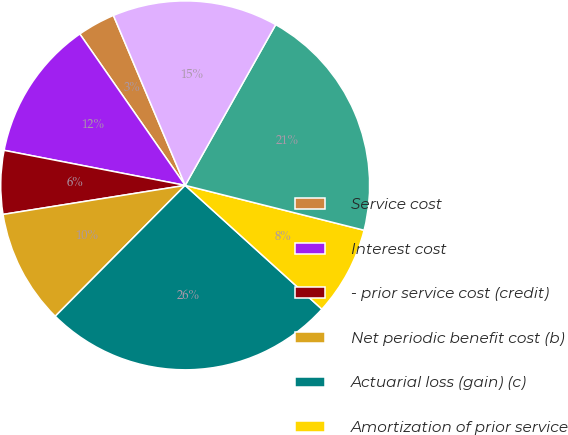<chart> <loc_0><loc_0><loc_500><loc_500><pie_chart><fcel>Service cost<fcel>Interest cost<fcel>- prior service cost (credit)<fcel>Net periodic benefit cost (b)<fcel>Actuarial loss (gain) (c)<fcel>Amortization of prior service<fcel>Total recognized in other<fcel>Total recognized in net<nl><fcel>3.32%<fcel>12.28%<fcel>5.56%<fcel>10.04%<fcel>25.73%<fcel>7.8%<fcel>20.75%<fcel>14.52%<nl></chart> 